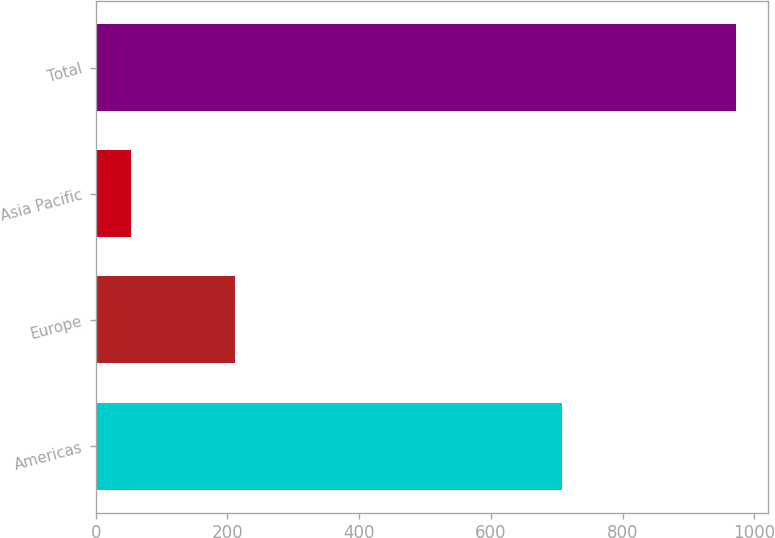Convert chart to OTSL. <chart><loc_0><loc_0><loc_500><loc_500><bar_chart><fcel>Americas<fcel>Europe<fcel>Asia Pacific<fcel>Total<nl><fcel>707.3<fcel>211.8<fcel>52.8<fcel>971.9<nl></chart> 